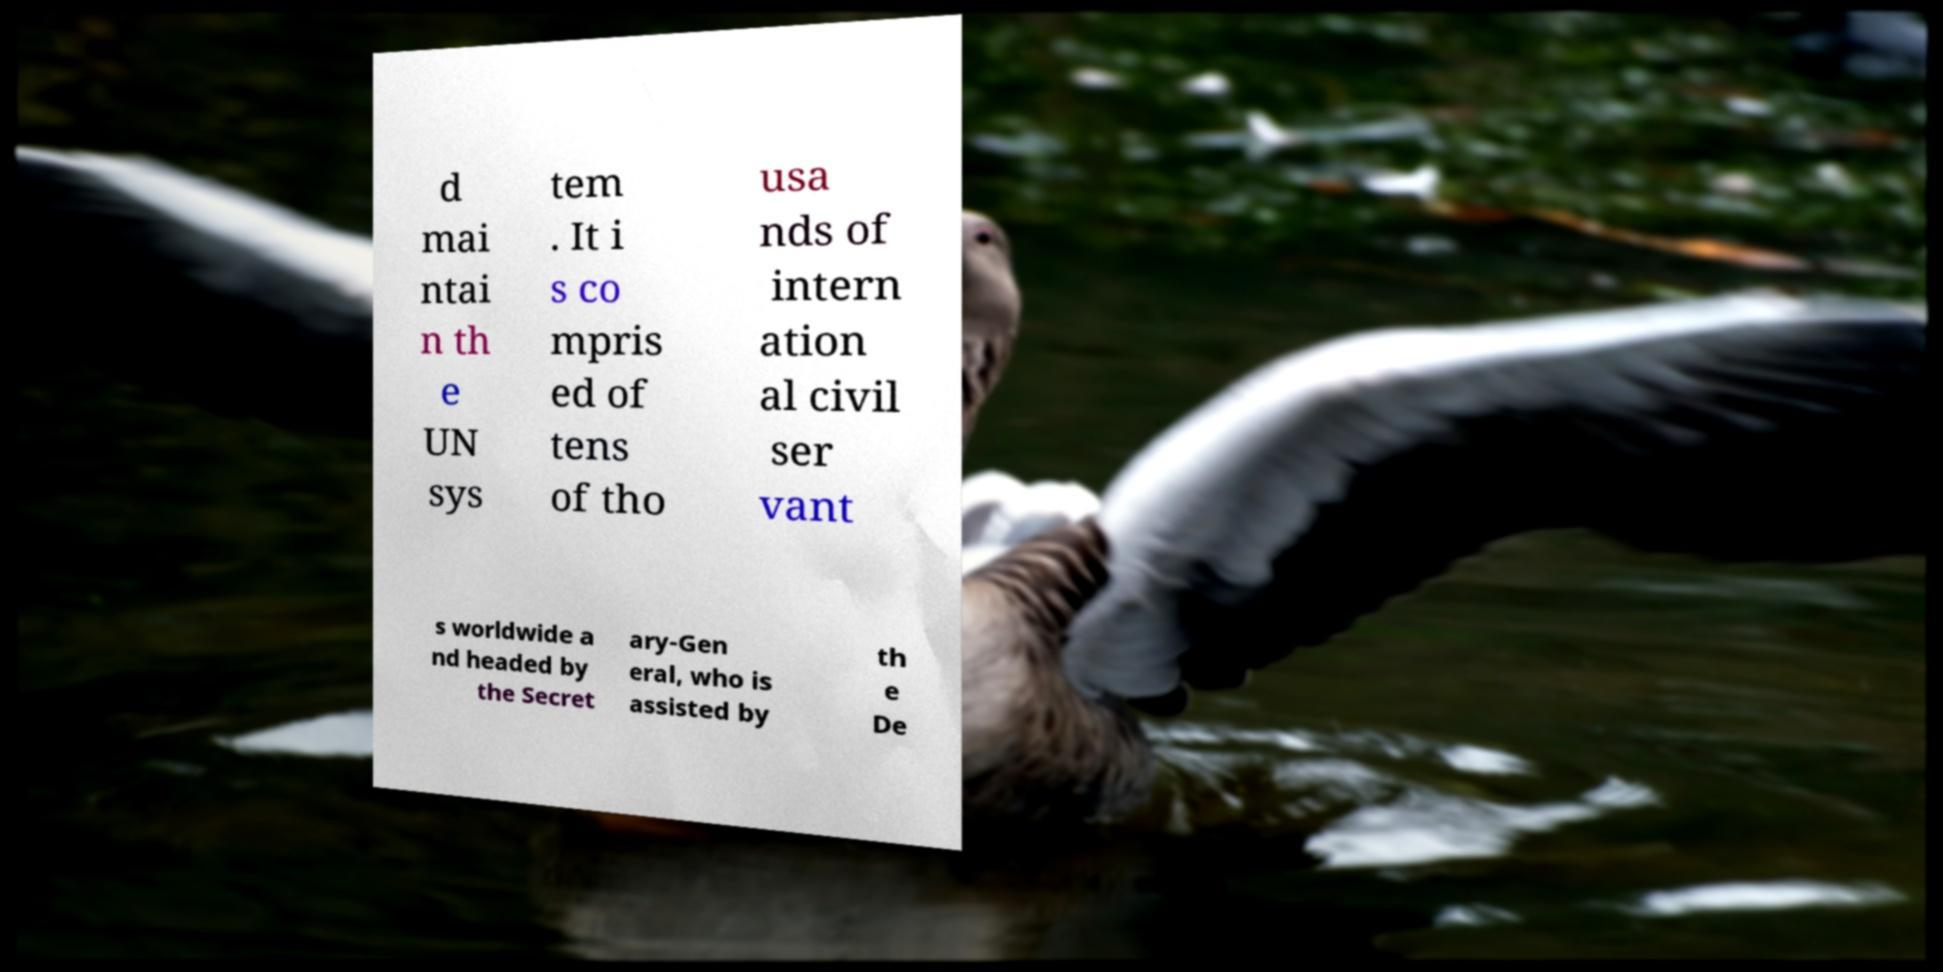Please read and relay the text visible in this image. What does it say? d mai ntai n th e UN sys tem . It i s co mpris ed of tens of tho usa nds of intern ation al civil ser vant s worldwide a nd headed by the Secret ary-Gen eral, who is assisted by th e De 